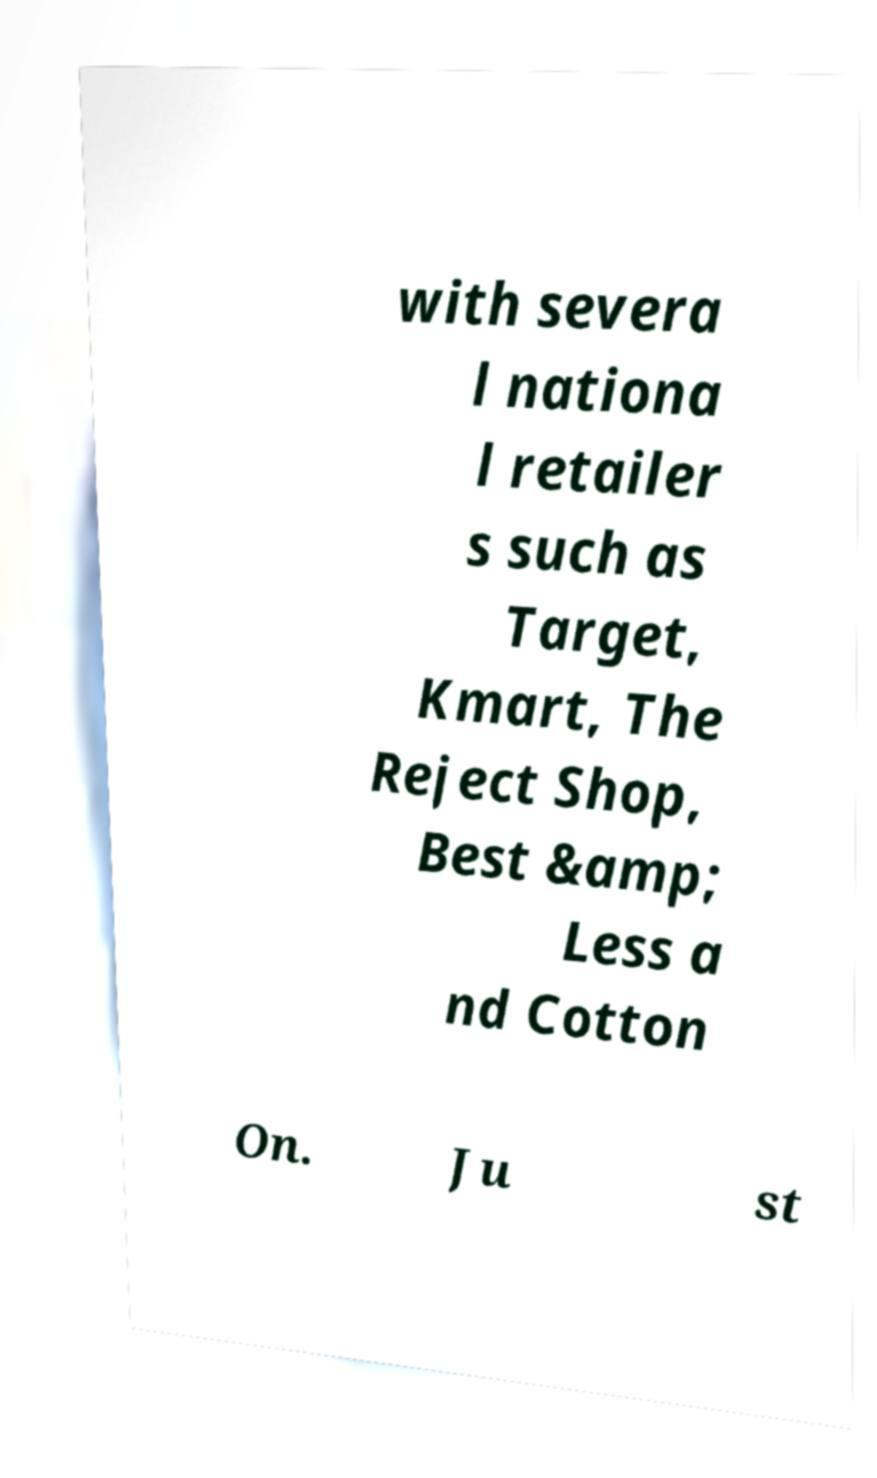I need the written content from this picture converted into text. Can you do that? with severa l nationa l retailer s such as Target, Kmart, The Reject Shop, Best &amp; Less a nd Cotton On. Ju st 